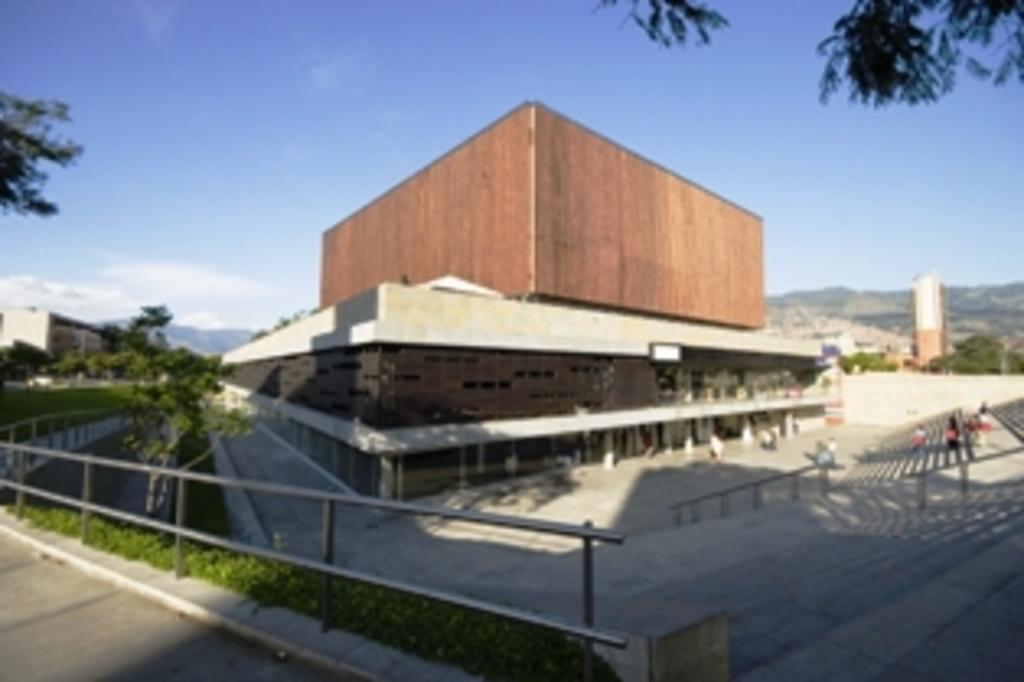How would you summarize this image in a sentence or two? In this picture I can see iron rods, plants, trees, buildings, hills, and in the background there is sky. 